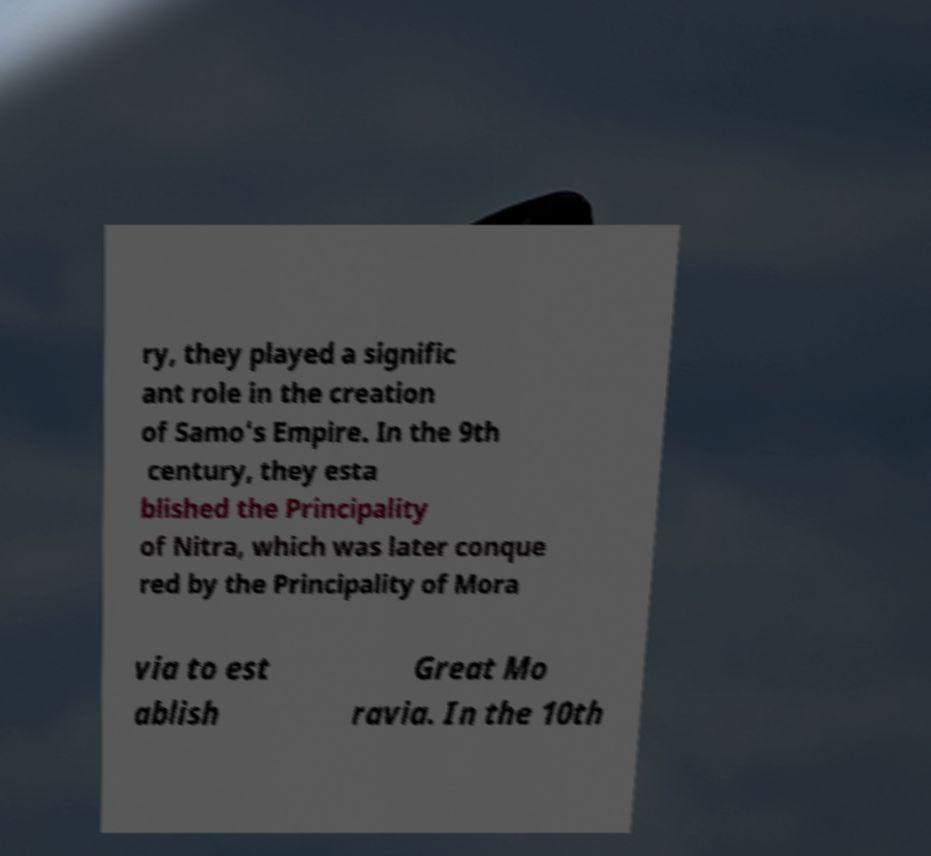What messages or text are displayed in this image? I need them in a readable, typed format. ry, they played a signific ant role in the creation of Samo's Empire. In the 9th century, they esta blished the Principality of Nitra, which was later conque red by the Principality of Mora via to est ablish Great Mo ravia. In the 10th 